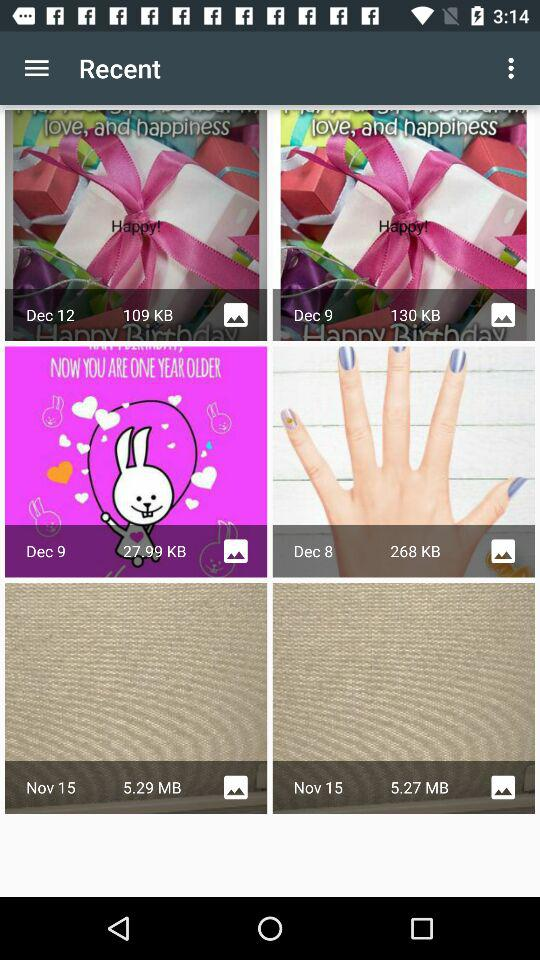What is the size of the "Dec 8" folder? The size of the "Dec 8" folder is 268 KB. 